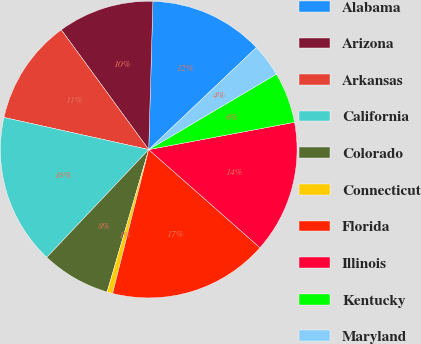Convert chart to OTSL. <chart><loc_0><loc_0><loc_500><loc_500><pie_chart><fcel>Alabama<fcel>Arizona<fcel>Arkansas<fcel>California<fcel>Colorado<fcel>Connecticut<fcel>Florida<fcel>Illinois<fcel>Kentucky<fcel>Maryland<nl><fcel>12.47%<fcel>10.49%<fcel>11.48%<fcel>16.42%<fcel>7.53%<fcel>0.61%<fcel>17.41%<fcel>14.45%<fcel>5.55%<fcel>3.58%<nl></chart> 